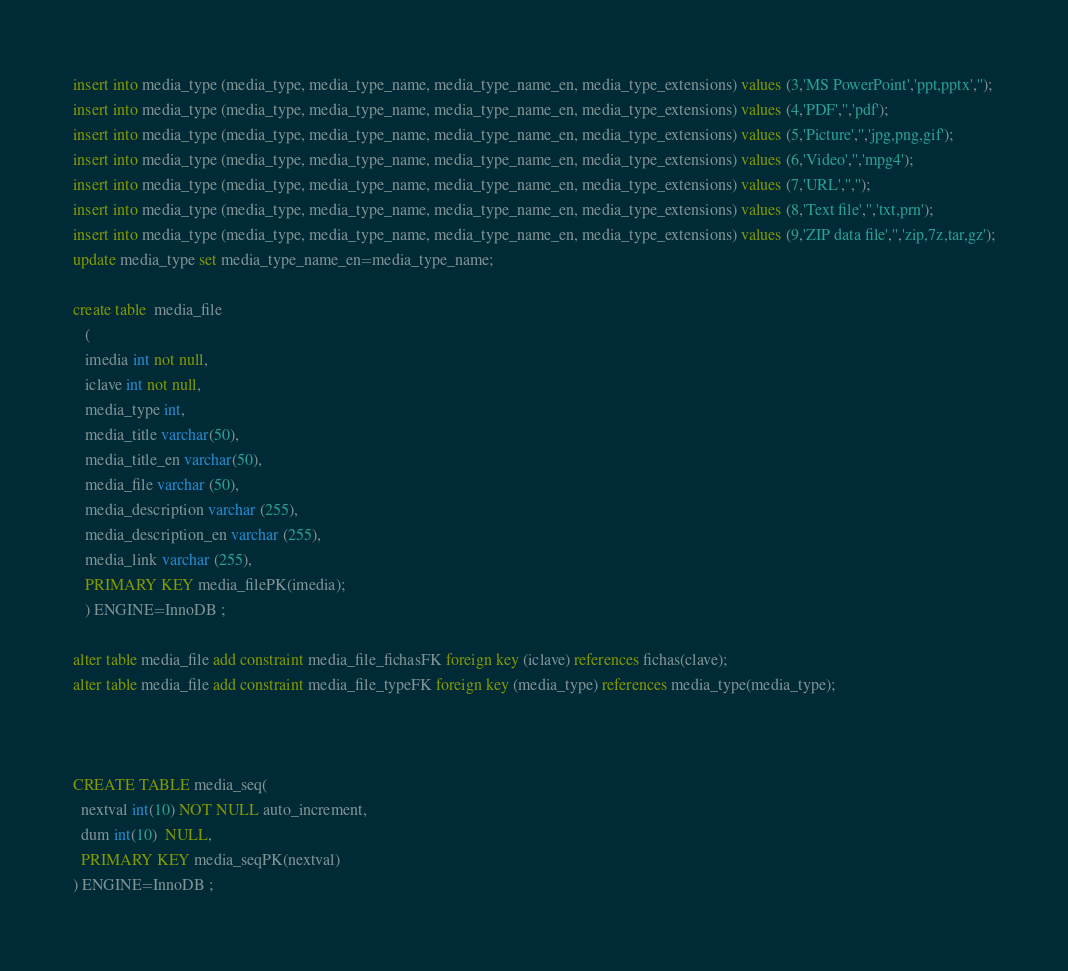Convert code to text. <code><loc_0><loc_0><loc_500><loc_500><_SQL_>insert into media_type (media_type, media_type_name, media_type_name_en, media_type_extensions) values (3,'MS PowerPoint','ppt,pptx','');
insert into media_type (media_type, media_type_name, media_type_name_en, media_type_extensions) values (4,'PDF','','pdf');
insert into media_type (media_type, media_type_name, media_type_name_en, media_type_extensions) values (5,'Picture','','jpg,png,gif');
insert into media_type (media_type, media_type_name, media_type_name_en, media_type_extensions) values (6,'Video','','mpg4');
insert into media_type (media_type, media_type_name, media_type_name_en, media_type_extensions) values (7,'URL','','');
insert into media_type (media_type, media_type_name, media_type_name_en, media_type_extensions) values (8,'Text file','','txt,prn');
insert into media_type (media_type, media_type_name, media_type_name_en, media_type_extensions) values (9,'ZIP data file','','zip,7z,tar,gz');
update media_type set media_type_name_en=media_type_name;

create table  media_file 
   (
   imedia int not null,
   iclave int not null,
   media_type int,
   media_title varchar(50),
   media_title_en varchar(50),
   media_file varchar (50),
   media_description varchar (255),
   media_description_en varchar (255),
   media_link varchar (255),
   PRIMARY KEY media_filePK(imedia);
   ) ENGINE=InnoDB ;

alter table media_file add constraint media_file_fichasFK foreign key (iclave) references fichas(clave);
alter table media_file add constraint media_file_typeFK foreign key (media_type) references media_type(media_type);



CREATE TABLE media_seq(
  nextval int(10) NOT NULL auto_increment,
  dum int(10)  NULL,
  PRIMARY KEY media_seqPK(nextval)
) ENGINE=InnoDB ;




</code> 